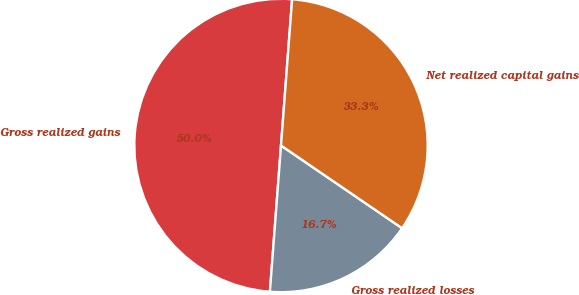<chart> <loc_0><loc_0><loc_500><loc_500><pie_chart><fcel>Gross realized gains<fcel>Gross realized losses<fcel>Net realized capital gains<nl><fcel>50.0%<fcel>16.67%<fcel>33.33%<nl></chart> 